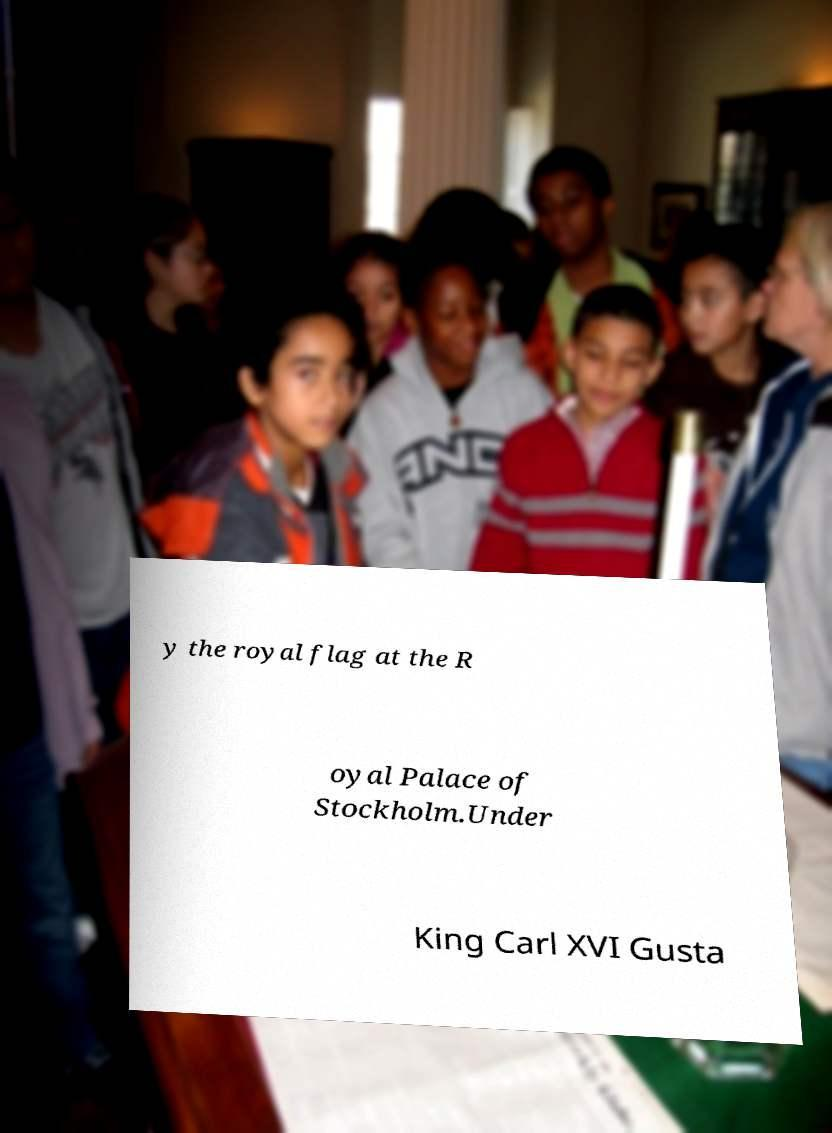I need the written content from this picture converted into text. Can you do that? y the royal flag at the R oyal Palace of Stockholm.Under King Carl XVI Gusta 